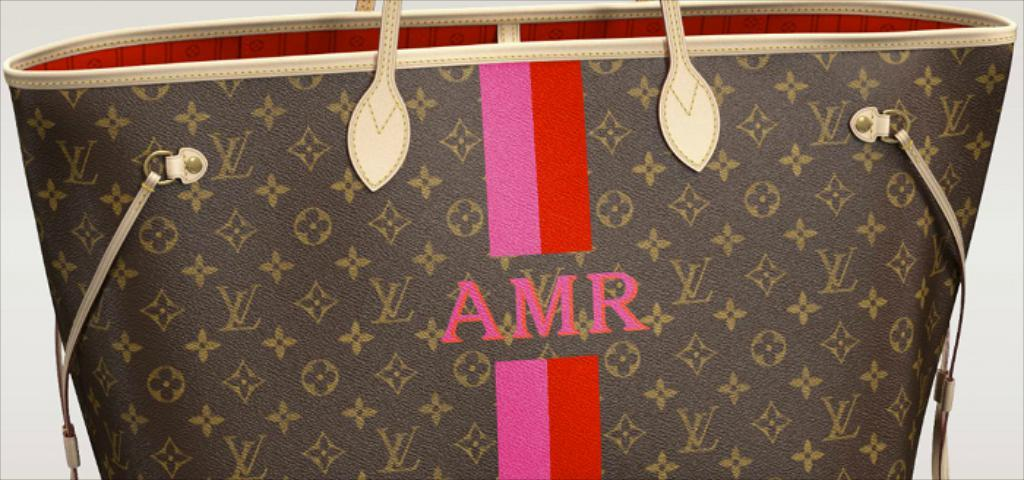What object can be seen in the image? There is a bag in the image. What rule is being enforced by the geese in the image? There are no geese present in the image, and therefore no rule enforcement can be observed. What type of sack is visible in the image? There is no sack present in the image; it is a bag. 